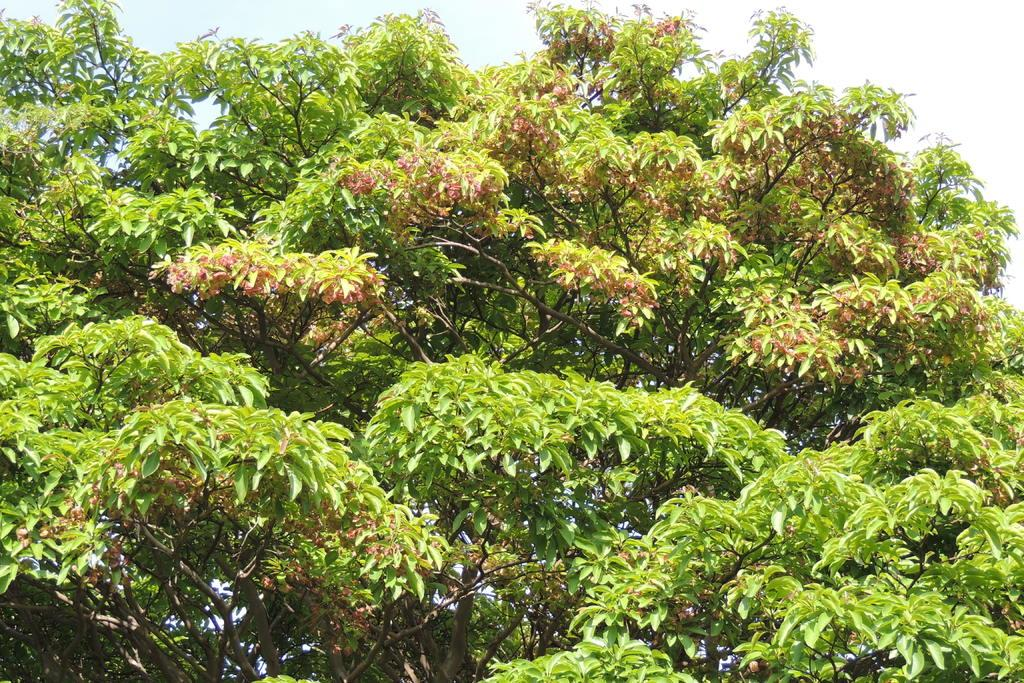What type of natural element is present in the image? There is a tree in the image. Where is the throne located in the image? There is no throne present in the image. What type of bells can be heard ringing in the image? There are no bells present in the image, and therefore no sound can be heard. 